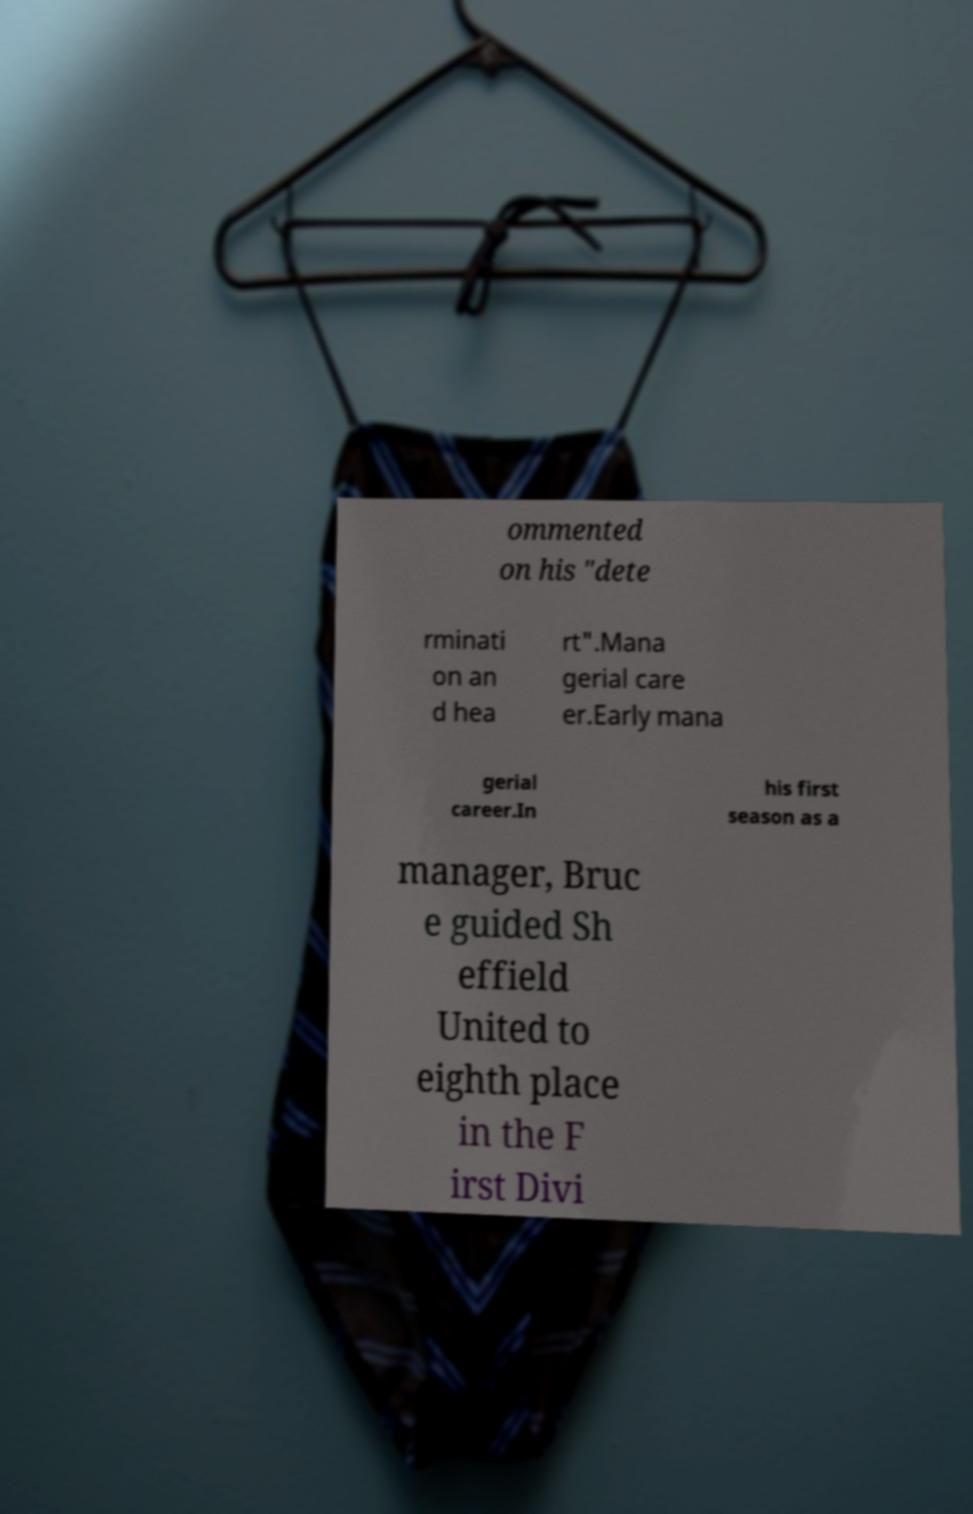There's text embedded in this image that I need extracted. Can you transcribe it verbatim? ommented on his "dete rminati on an d hea rt".Mana gerial care er.Early mana gerial career.In his first season as a manager, Bruc e guided Sh effield United to eighth place in the F irst Divi 